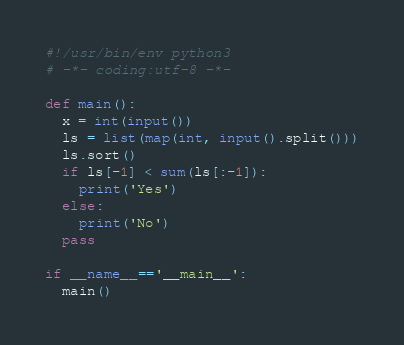Convert code to text. <code><loc_0><loc_0><loc_500><loc_500><_Python_>#!/usr/bin/env python3
# -*- coding:utf-8 -*-

def main():
  x = int(input())
  ls = list(map(int, input().split()))
  ls.sort()
  if ls[-1] < sum(ls[:-1]):
    print('Yes')
  else:
    print('No')
  pass

if __name__=='__main__':
  main()</code> 